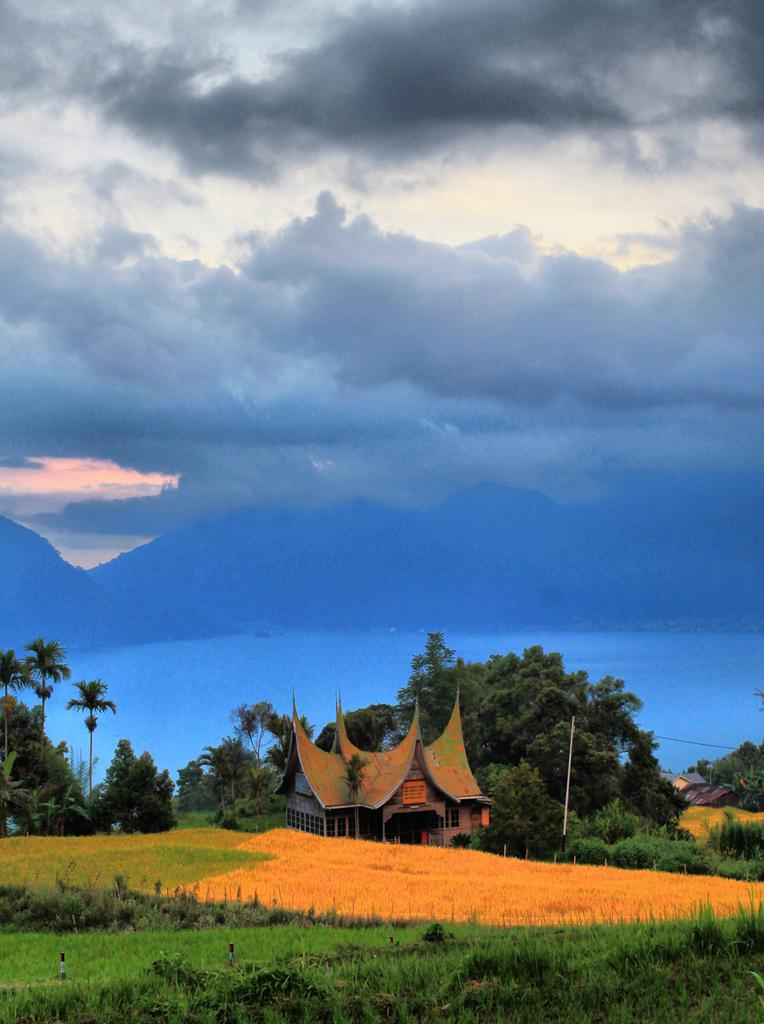What type of structure is visible in the image? There is a home in the image. Where is the home situated? The home is located in the middle of a grassland. What can be seen behind the home? There are trees behind the home. What is visible in the sky in the image? The sky is visible in the image, and clouds are present. What type of pleasure can be seen in the basket near the home? There is no basket or pleasure present in the image. 